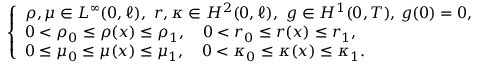<formula> <loc_0><loc_0><loc_500><loc_500>\begin{array} { r } { \left \{ \begin{array} { l l } { \rho , \mu \in L ^ { \infty } ( 0 , \ell ) , \ r , \kappa \in H ^ { 2 } ( 0 , \ell ) , \ g \in H ^ { 1 } ( 0 , T ) , \, g ( 0 ) = 0 , } \\ { 0 < \rho _ { 0 } \leq \rho ( x ) \leq \rho _ { 1 } , \quad 0 < r _ { 0 } \leq r ( x ) \leq r _ { 1 } , } \\ { 0 \leq \mu _ { 0 } \leq \mu ( x ) \leq \mu _ { 1 } , \quad 0 < \kappa _ { 0 } \leq \kappa ( x ) \leq \kappa _ { 1 } . } \end{array} } \end{array}</formula> 